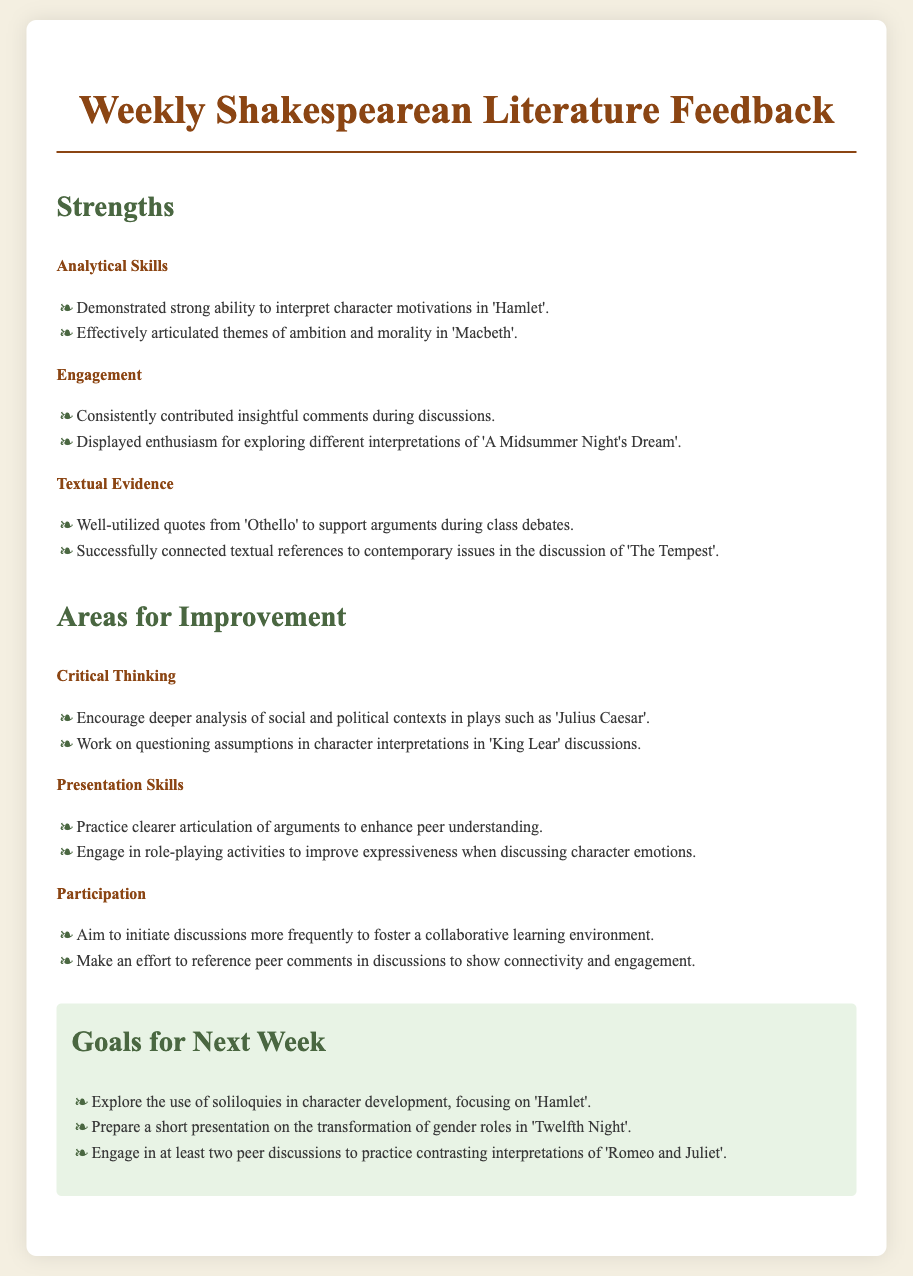What are the strengths mentioned in the feedback? The strengths are categorized into Analytical Skills, Engagement, and Textual Evidence, with specific examples provided for each.
Answer: Analytical Skills, Engagement, Textual Evidence Which character motivations were specifically interpreted well? The document states strong abilities to interpret character motivations for 'Hamlet'.
Answer: Hamlet What is one area identified for improvement regarding critical thinking? The document mentions encouraging deeper analysis of social and political contexts in 'Julius Caesar' as an area for improvement.
Answer: Julius Caesar How many goals are set for the next week? The document lists three specific goals for the next week.
Answer: Three What skill is suggested to be practiced for better presentation? The document suggests practicing clearer articulation of arguments to enhance peer understanding.
Answer: Clearer articulation Which play is suggested for exploring soliloquies in character development? The document specifically mentions focusing on 'Hamlet' for the use of soliloquies in character development.
Answer: Hamlet What is highlighted as a strength in engagement? The document states that the student consistently contributed insightful comments during discussions.
Answer: Consistently contributed insightful comments What aspect of participation is encouraged for improvement? The document encourages initiating discussions more frequently to foster collaboration.
Answer: Initiate discussions more frequently 